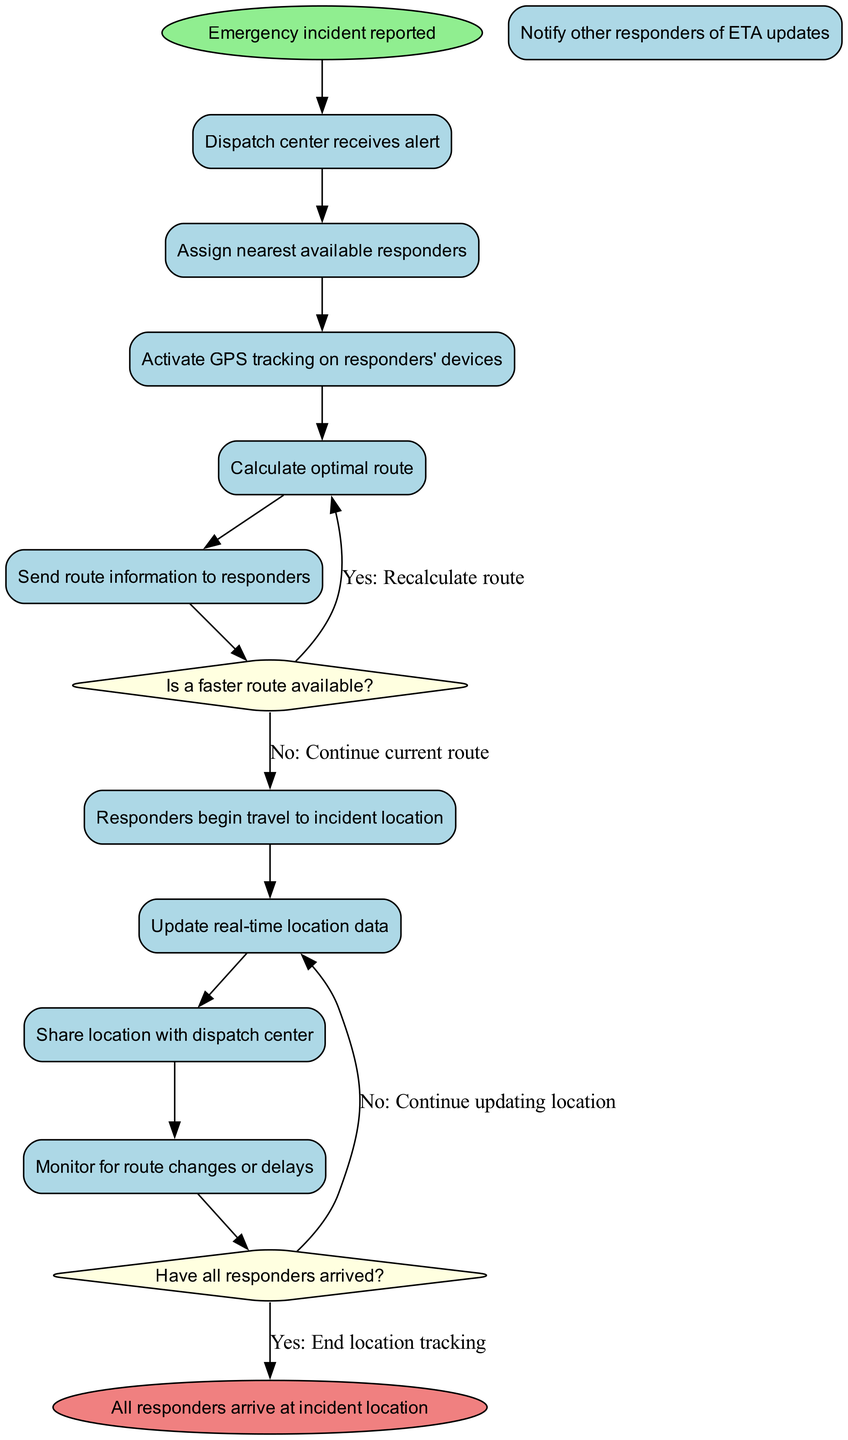What is the initial node in the diagram? The initial node in the diagram is "Emergency incident reported."
Answer: Emergency incident reported How many activities are represented in the diagram? The diagram contains ten activities, which include actions from receiving an alert to notifying other responders.
Answer: 10 What is the last activity before the first decision node? The last activity before the first decision node is "Send route information to responders."
Answer: Send route information to responders What happens if a faster route is available according to the diagram? If a faster route is available, the flow indicates that the route will be recalculated, moving to the corresponding activity.
Answer: Recalculate route What is the response if all responders have not yet arrived? If not all responders have arrived, the flow specifies to continue updating the location information rather than ending the tracking.
Answer: Continue updating location Which activity follows the decision "Is a faster route available?" if the answer is no? If the answer is no to the decision "Is a faster route available?", the flow continues to the activity "Responders begin travel to incident location."
Answer: Responders begin travel to incident location How many decision nodes are present in the diagram? There are two decision nodes present in the diagram, each leading to different flow paths based on the responses.
Answer: 2 What is the end node of the activity diagram? The end node of the activity diagram is "All responders arrive at incident location."
Answer: All responders arrive at incident location What is the first activity that occurs after the initial node? The first activity that occurs after the initial node is "Dispatch center receives alert."
Answer: Dispatch center receives alert 